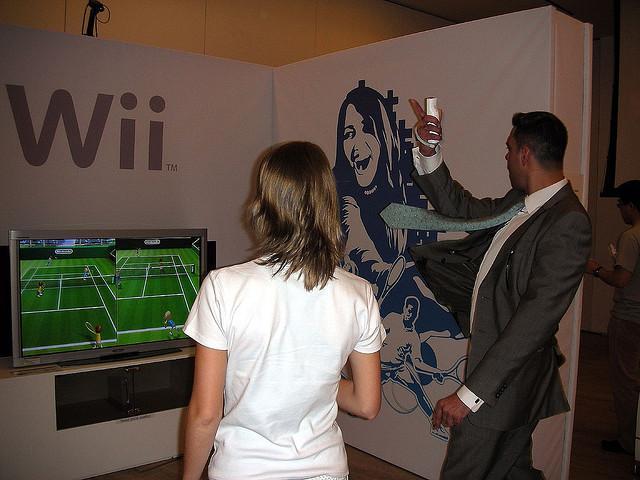How many people are watching?
Give a very brief answer. 2. How many people are in the photo?
Give a very brief answer. 3. 